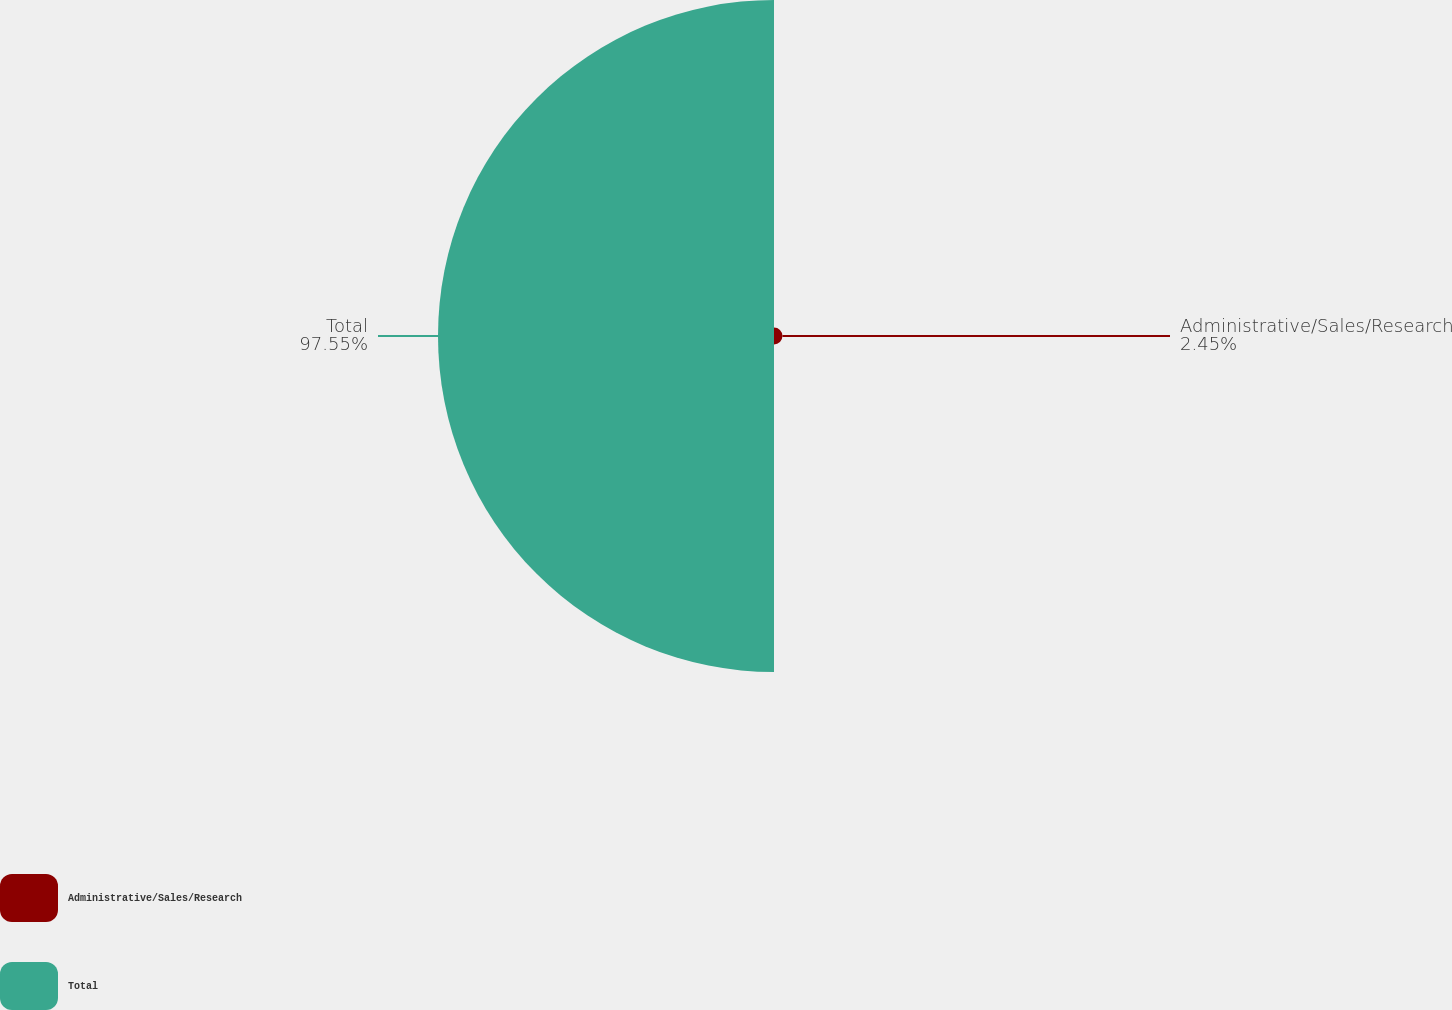Convert chart. <chart><loc_0><loc_0><loc_500><loc_500><pie_chart><fcel>Administrative/Sales/Research<fcel>Total<nl><fcel>2.45%<fcel>97.55%<nl></chart> 